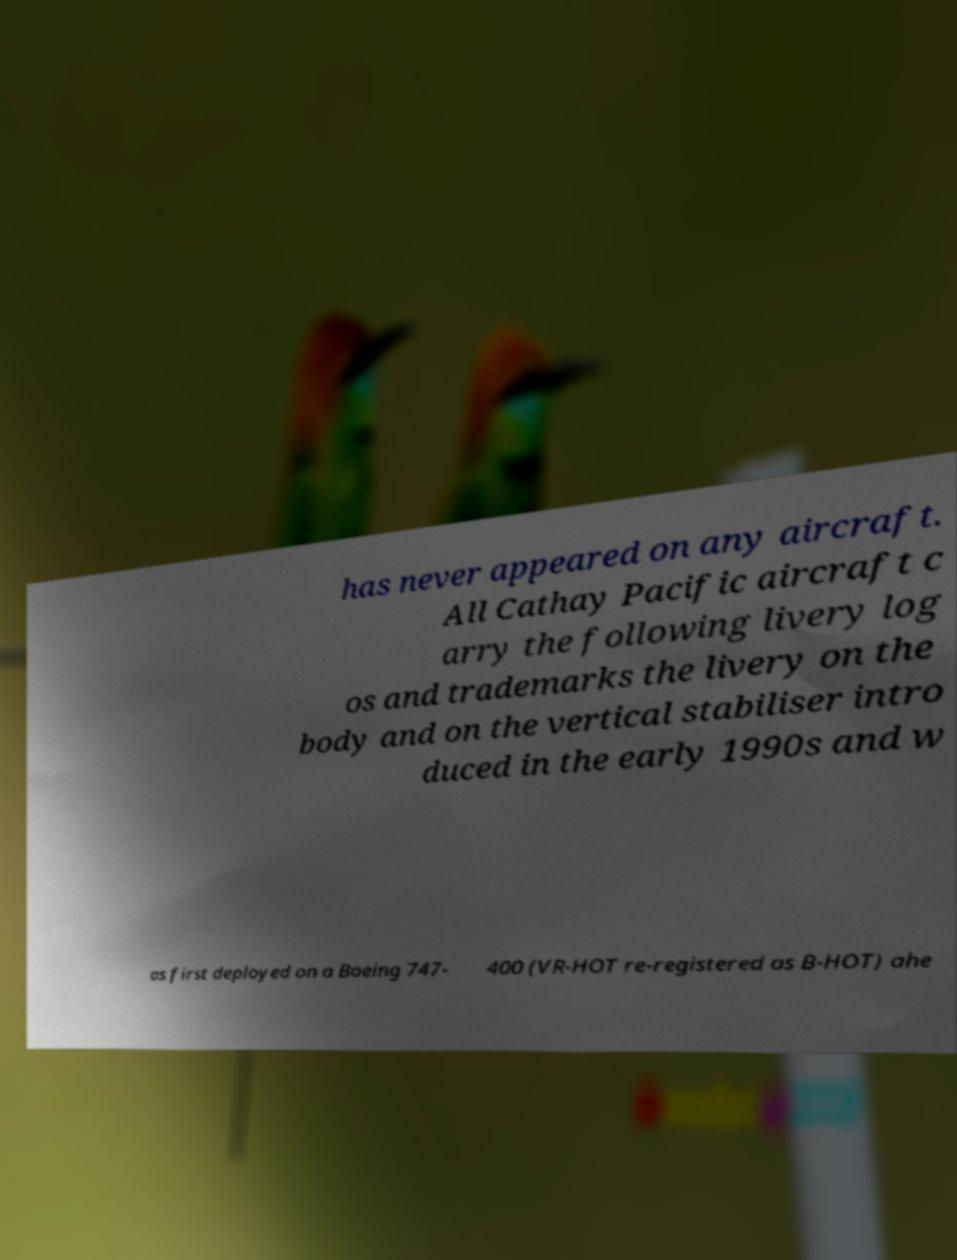There's text embedded in this image that I need extracted. Can you transcribe it verbatim? has never appeared on any aircraft. All Cathay Pacific aircraft c arry the following livery log os and trademarks the livery on the body and on the vertical stabiliser intro duced in the early 1990s and w as first deployed on a Boeing 747- 400 (VR-HOT re-registered as B-HOT) ahe 